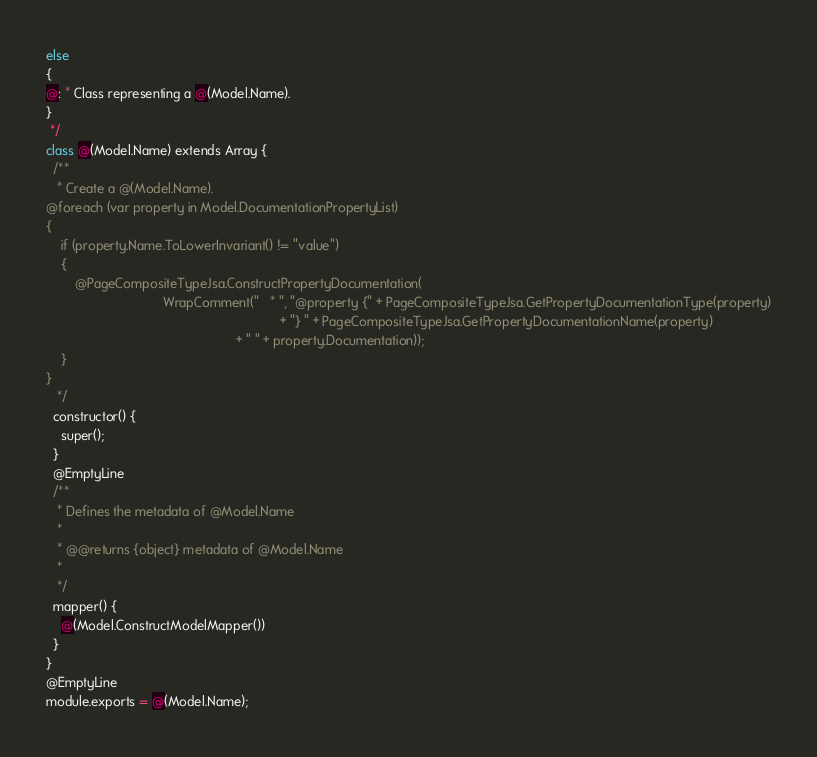<code> <loc_0><loc_0><loc_500><loc_500><_C#_>else
{
@: * Class representing a @(Model.Name).
}
 */
class @(Model.Name) extends Array {
  /**
   * Create a @(Model.Name).
@foreach (var property in Model.DocumentationPropertyList)
{
    if (property.Name.ToLowerInvariant() != "value")
    {
        @PageCompositeTypeJsa.ConstructPropertyDocumentation(
                                WrapComment("   * ", "@property {" + PageCompositeTypeJsa.GetPropertyDocumentationType(property)
                                                                + "} " + PageCompositeTypeJsa.GetPropertyDocumentationName(property)
                                                    + " " + property.Documentation));
    }
}
   */
  constructor() {
    super();
  }
  @EmptyLine
  /**
   * Defines the metadata of @Model.Name
   *
   * @@returns {object} metadata of @Model.Name
   *
   */
  mapper() {
    @(Model.ConstructModelMapper())
  }
}
@EmptyLine
module.exports = @(Model.Name);</code> 